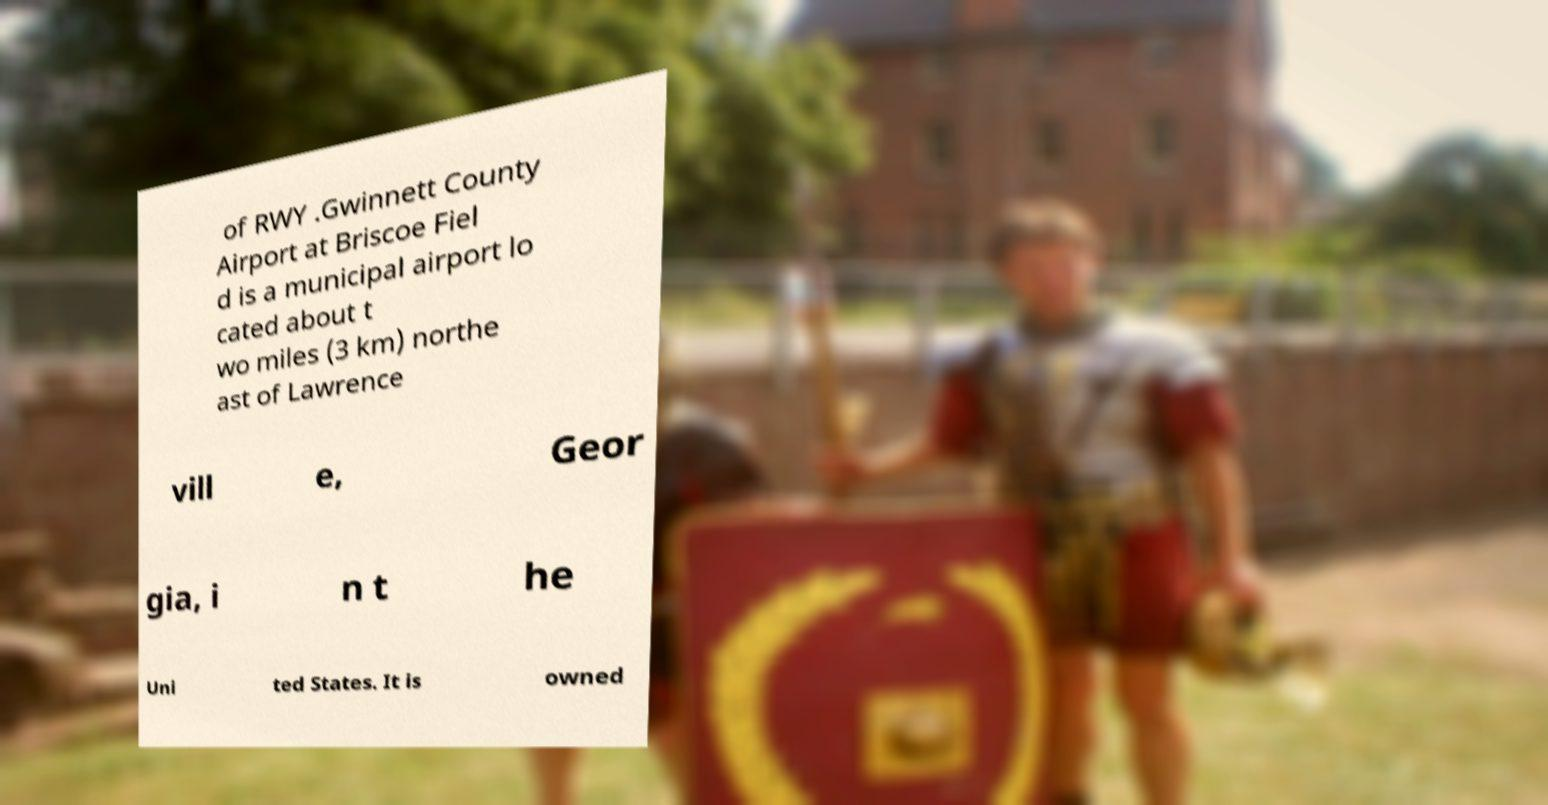Could you extract and type out the text from this image? of RWY .Gwinnett County Airport at Briscoe Fiel d is a municipal airport lo cated about t wo miles (3 km) northe ast of Lawrence vill e, Geor gia, i n t he Uni ted States. It is owned 